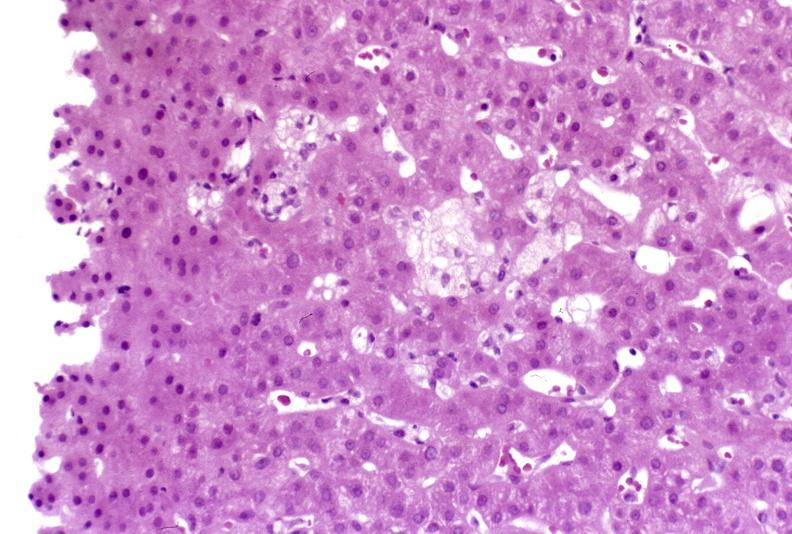what does this image show?
Answer the question using a single word or phrase. Recovery of ducts 